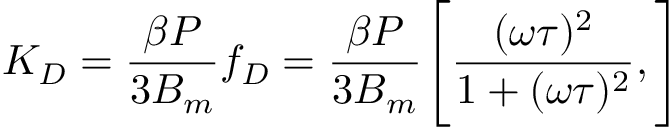<formula> <loc_0><loc_0><loc_500><loc_500>K _ { D } = \frac { \beta P } { 3 B _ { m } } f _ { D } = \frac { \beta P } { 3 B _ { m } } \left [ \frac { ( \omega \tau ) ^ { 2 } } { 1 + ( \omega \tau ) ^ { 2 } } , \right ]</formula> 